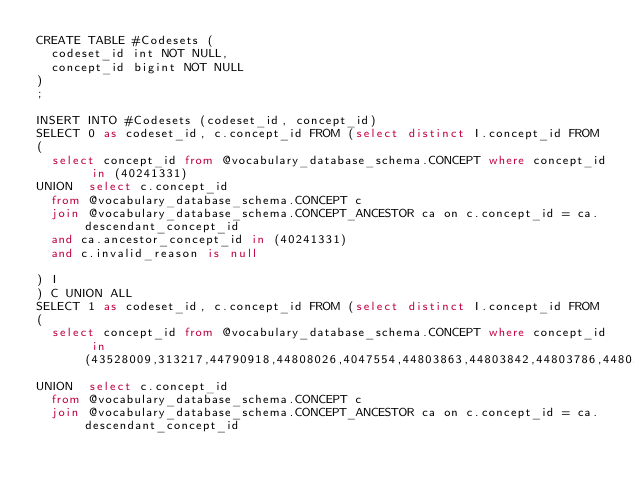<code> <loc_0><loc_0><loc_500><loc_500><_SQL_>CREATE TABLE #Codesets (
  codeset_id int NOT NULL,
  concept_id bigint NOT NULL
)
;

INSERT INTO #Codesets (codeset_id, concept_id)
SELECT 0 as codeset_id, c.concept_id FROM (select distinct I.concept_id FROM
( 
  select concept_id from @vocabulary_database_schema.CONCEPT where concept_id in (40241331)
UNION  select c.concept_id
  from @vocabulary_database_schema.CONCEPT c
  join @vocabulary_database_schema.CONCEPT_ANCESTOR ca on c.concept_id = ca.descendant_concept_id
  and ca.ancestor_concept_id in (40241331)
  and c.invalid_reason is null

) I
) C UNION ALL 
SELECT 1 as codeset_id, c.concept_id FROM (select distinct I.concept_id FROM
( 
  select concept_id from @vocabulary_database_schema.CONCEPT where concept_id in (43528009,313217,44790918,44808026,4047554,44803863,44803842,44803786,44803702,44803845,314665,2617598,2101903,4064452,4065288,40761369,4194288,4323077,4180108,4020234,42709991,4181800,42736318,45769228,4139517)
UNION  select c.concept_id
  from @vocabulary_database_schema.CONCEPT c
  join @vocabulary_database_schema.CONCEPT_ANCESTOR ca on c.concept_id = ca.descendant_concept_id</code> 